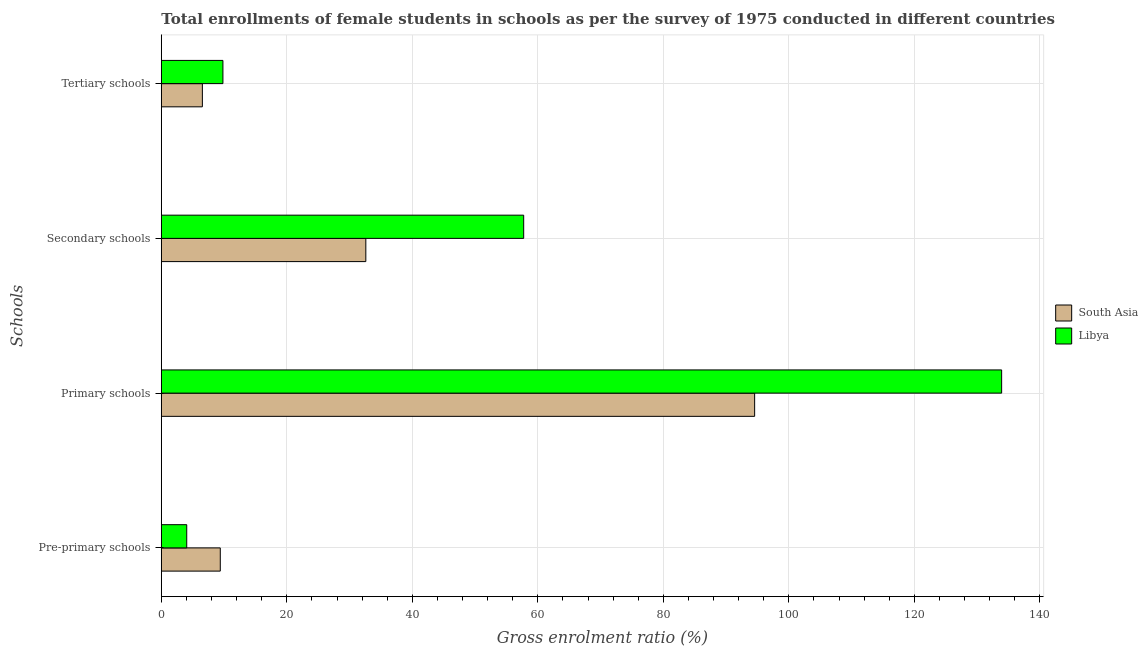How many groups of bars are there?
Your response must be concise. 4. Are the number of bars per tick equal to the number of legend labels?
Make the answer very short. Yes. What is the label of the 1st group of bars from the top?
Provide a short and direct response. Tertiary schools. What is the gross enrolment ratio(female) in tertiary schools in Libya?
Offer a terse response. 9.82. Across all countries, what is the maximum gross enrolment ratio(female) in secondary schools?
Keep it short and to the point. 57.74. Across all countries, what is the minimum gross enrolment ratio(female) in tertiary schools?
Offer a very short reply. 6.54. In which country was the gross enrolment ratio(female) in secondary schools maximum?
Your response must be concise. Libya. In which country was the gross enrolment ratio(female) in pre-primary schools minimum?
Offer a very short reply. Libya. What is the total gross enrolment ratio(female) in pre-primary schools in the graph?
Make the answer very short. 13.45. What is the difference between the gross enrolment ratio(female) in tertiary schools in South Asia and that in Libya?
Your answer should be very brief. -3.27. What is the difference between the gross enrolment ratio(female) in secondary schools in South Asia and the gross enrolment ratio(female) in pre-primary schools in Libya?
Your response must be concise. 28.54. What is the average gross enrolment ratio(female) in secondary schools per country?
Provide a short and direct response. 45.17. What is the difference between the gross enrolment ratio(female) in tertiary schools and gross enrolment ratio(female) in pre-primary schools in Libya?
Ensure brevity in your answer.  5.77. What is the ratio of the gross enrolment ratio(female) in pre-primary schools in South Asia to that in Libya?
Provide a short and direct response. 2.32. Is the gross enrolment ratio(female) in tertiary schools in Libya less than that in South Asia?
Your answer should be very brief. No. Is the difference between the gross enrolment ratio(female) in tertiary schools in Libya and South Asia greater than the difference between the gross enrolment ratio(female) in pre-primary schools in Libya and South Asia?
Give a very brief answer. Yes. What is the difference between the highest and the second highest gross enrolment ratio(female) in pre-primary schools?
Offer a terse response. 5.35. What is the difference between the highest and the lowest gross enrolment ratio(female) in tertiary schools?
Your answer should be very brief. 3.27. Is the sum of the gross enrolment ratio(female) in pre-primary schools in South Asia and Libya greater than the maximum gross enrolment ratio(female) in secondary schools across all countries?
Offer a terse response. No. What does the 2nd bar from the bottom in Pre-primary schools represents?
Provide a succinct answer. Libya. What is the difference between two consecutive major ticks on the X-axis?
Ensure brevity in your answer.  20. Are the values on the major ticks of X-axis written in scientific E-notation?
Offer a terse response. No. Does the graph contain any zero values?
Your answer should be compact. No. What is the title of the graph?
Offer a very short reply. Total enrollments of female students in schools as per the survey of 1975 conducted in different countries. What is the label or title of the X-axis?
Make the answer very short. Gross enrolment ratio (%). What is the label or title of the Y-axis?
Offer a terse response. Schools. What is the Gross enrolment ratio (%) in South Asia in Pre-primary schools?
Offer a very short reply. 9.4. What is the Gross enrolment ratio (%) of Libya in Pre-primary schools?
Give a very brief answer. 4.05. What is the Gross enrolment ratio (%) of South Asia in Primary schools?
Give a very brief answer. 94.55. What is the Gross enrolment ratio (%) in Libya in Primary schools?
Your response must be concise. 133.91. What is the Gross enrolment ratio (%) in South Asia in Secondary schools?
Your answer should be very brief. 32.59. What is the Gross enrolment ratio (%) in Libya in Secondary schools?
Your answer should be very brief. 57.74. What is the Gross enrolment ratio (%) of South Asia in Tertiary schools?
Your answer should be very brief. 6.54. What is the Gross enrolment ratio (%) in Libya in Tertiary schools?
Offer a very short reply. 9.82. Across all Schools, what is the maximum Gross enrolment ratio (%) of South Asia?
Give a very brief answer. 94.55. Across all Schools, what is the maximum Gross enrolment ratio (%) in Libya?
Ensure brevity in your answer.  133.91. Across all Schools, what is the minimum Gross enrolment ratio (%) in South Asia?
Ensure brevity in your answer.  6.54. Across all Schools, what is the minimum Gross enrolment ratio (%) of Libya?
Make the answer very short. 4.05. What is the total Gross enrolment ratio (%) of South Asia in the graph?
Keep it short and to the point. 143.07. What is the total Gross enrolment ratio (%) in Libya in the graph?
Your answer should be compact. 205.52. What is the difference between the Gross enrolment ratio (%) in South Asia in Pre-primary schools and that in Primary schools?
Ensure brevity in your answer.  -85.15. What is the difference between the Gross enrolment ratio (%) of Libya in Pre-primary schools and that in Primary schools?
Keep it short and to the point. -129.86. What is the difference between the Gross enrolment ratio (%) in South Asia in Pre-primary schools and that in Secondary schools?
Provide a short and direct response. -23.19. What is the difference between the Gross enrolment ratio (%) in Libya in Pre-primary schools and that in Secondary schools?
Make the answer very short. -53.69. What is the difference between the Gross enrolment ratio (%) of South Asia in Pre-primary schools and that in Tertiary schools?
Offer a very short reply. 2.85. What is the difference between the Gross enrolment ratio (%) of Libya in Pre-primary schools and that in Tertiary schools?
Keep it short and to the point. -5.77. What is the difference between the Gross enrolment ratio (%) in South Asia in Primary schools and that in Secondary schools?
Your response must be concise. 61.96. What is the difference between the Gross enrolment ratio (%) in Libya in Primary schools and that in Secondary schools?
Provide a succinct answer. 76.16. What is the difference between the Gross enrolment ratio (%) of South Asia in Primary schools and that in Tertiary schools?
Your response must be concise. 88. What is the difference between the Gross enrolment ratio (%) of Libya in Primary schools and that in Tertiary schools?
Give a very brief answer. 124.09. What is the difference between the Gross enrolment ratio (%) in South Asia in Secondary schools and that in Tertiary schools?
Provide a short and direct response. 26.05. What is the difference between the Gross enrolment ratio (%) in Libya in Secondary schools and that in Tertiary schools?
Your response must be concise. 47.93. What is the difference between the Gross enrolment ratio (%) of South Asia in Pre-primary schools and the Gross enrolment ratio (%) of Libya in Primary schools?
Give a very brief answer. -124.51. What is the difference between the Gross enrolment ratio (%) in South Asia in Pre-primary schools and the Gross enrolment ratio (%) in Libya in Secondary schools?
Your response must be concise. -48.35. What is the difference between the Gross enrolment ratio (%) of South Asia in Pre-primary schools and the Gross enrolment ratio (%) of Libya in Tertiary schools?
Ensure brevity in your answer.  -0.42. What is the difference between the Gross enrolment ratio (%) in South Asia in Primary schools and the Gross enrolment ratio (%) in Libya in Secondary schools?
Make the answer very short. 36.8. What is the difference between the Gross enrolment ratio (%) in South Asia in Primary schools and the Gross enrolment ratio (%) in Libya in Tertiary schools?
Keep it short and to the point. 84.73. What is the difference between the Gross enrolment ratio (%) of South Asia in Secondary schools and the Gross enrolment ratio (%) of Libya in Tertiary schools?
Your answer should be compact. 22.77. What is the average Gross enrolment ratio (%) of South Asia per Schools?
Ensure brevity in your answer.  35.77. What is the average Gross enrolment ratio (%) of Libya per Schools?
Ensure brevity in your answer.  51.38. What is the difference between the Gross enrolment ratio (%) of South Asia and Gross enrolment ratio (%) of Libya in Pre-primary schools?
Provide a short and direct response. 5.35. What is the difference between the Gross enrolment ratio (%) in South Asia and Gross enrolment ratio (%) in Libya in Primary schools?
Make the answer very short. -39.36. What is the difference between the Gross enrolment ratio (%) in South Asia and Gross enrolment ratio (%) in Libya in Secondary schools?
Ensure brevity in your answer.  -25.16. What is the difference between the Gross enrolment ratio (%) of South Asia and Gross enrolment ratio (%) of Libya in Tertiary schools?
Ensure brevity in your answer.  -3.27. What is the ratio of the Gross enrolment ratio (%) in South Asia in Pre-primary schools to that in Primary schools?
Offer a terse response. 0.1. What is the ratio of the Gross enrolment ratio (%) in Libya in Pre-primary schools to that in Primary schools?
Provide a succinct answer. 0.03. What is the ratio of the Gross enrolment ratio (%) in South Asia in Pre-primary schools to that in Secondary schools?
Your answer should be compact. 0.29. What is the ratio of the Gross enrolment ratio (%) of Libya in Pre-primary schools to that in Secondary schools?
Offer a very short reply. 0.07. What is the ratio of the Gross enrolment ratio (%) of South Asia in Pre-primary schools to that in Tertiary schools?
Ensure brevity in your answer.  1.44. What is the ratio of the Gross enrolment ratio (%) of Libya in Pre-primary schools to that in Tertiary schools?
Offer a terse response. 0.41. What is the ratio of the Gross enrolment ratio (%) of South Asia in Primary schools to that in Secondary schools?
Keep it short and to the point. 2.9. What is the ratio of the Gross enrolment ratio (%) in Libya in Primary schools to that in Secondary schools?
Provide a succinct answer. 2.32. What is the ratio of the Gross enrolment ratio (%) of South Asia in Primary schools to that in Tertiary schools?
Your response must be concise. 14.45. What is the ratio of the Gross enrolment ratio (%) in Libya in Primary schools to that in Tertiary schools?
Offer a very short reply. 13.64. What is the ratio of the Gross enrolment ratio (%) of South Asia in Secondary schools to that in Tertiary schools?
Offer a terse response. 4.98. What is the ratio of the Gross enrolment ratio (%) of Libya in Secondary schools to that in Tertiary schools?
Offer a terse response. 5.88. What is the difference between the highest and the second highest Gross enrolment ratio (%) in South Asia?
Your answer should be compact. 61.96. What is the difference between the highest and the second highest Gross enrolment ratio (%) in Libya?
Offer a very short reply. 76.16. What is the difference between the highest and the lowest Gross enrolment ratio (%) of South Asia?
Provide a short and direct response. 88. What is the difference between the highest and the lowest Gross enrolment ratio (%) of Libya?
Provide a succinct answer. 129.86. 